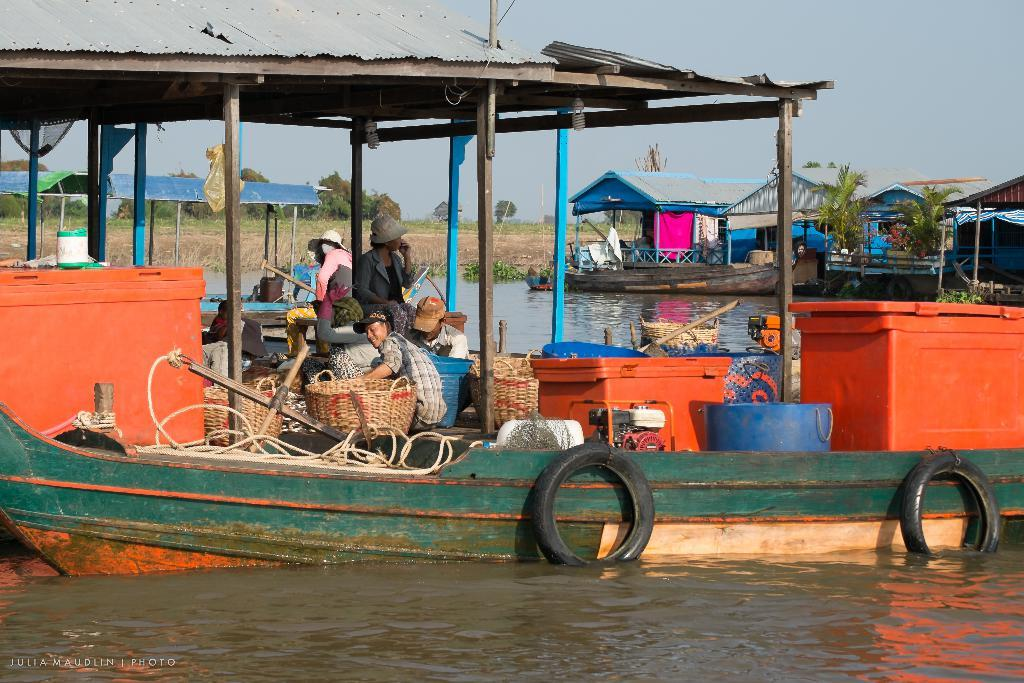What is floating on the water in the image? There are boats floating on the water in the image. What are the people in the boats doing? The people are sitting in the boats. What can be seen in the background of the image? There are trees, the ground, and the sky visible in the background of the image. What type of music can be heard coming from the bell in the image? There is no bell present in the image, and therefore no music can be heard. 